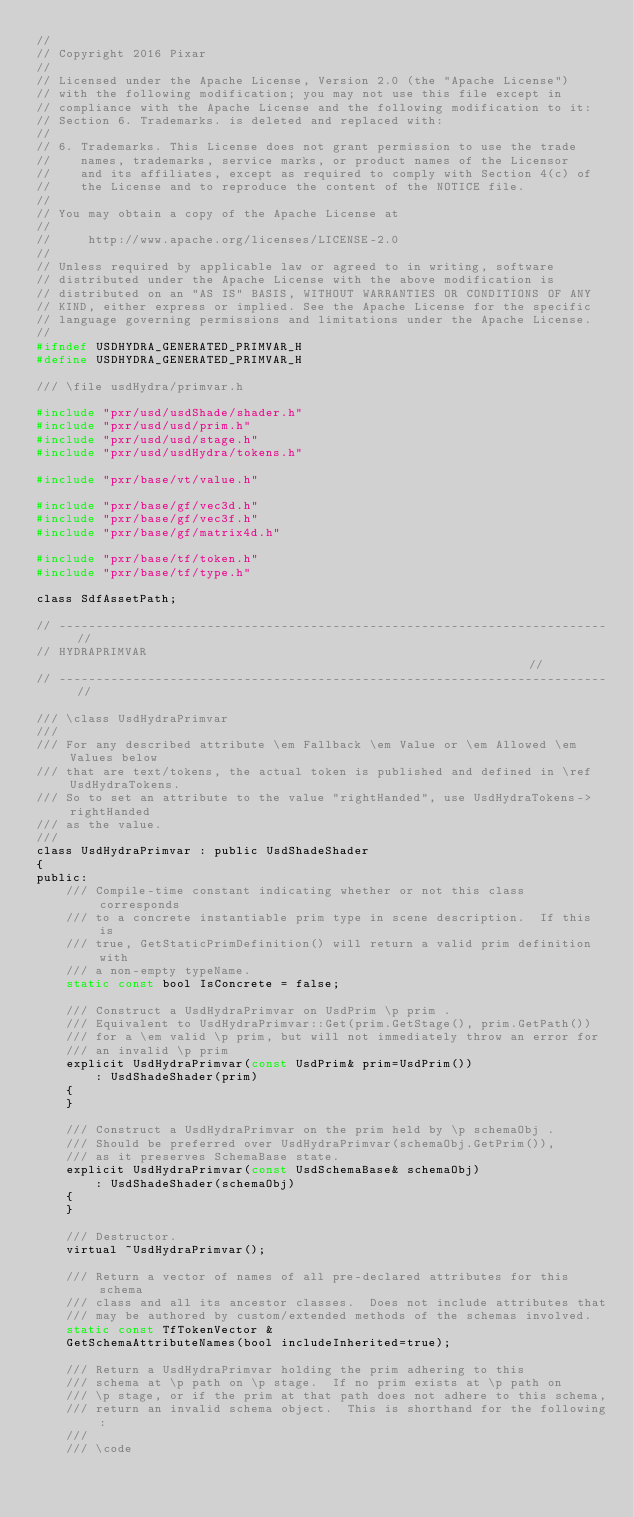<code> <loc_0><loc_0><loc_500><loc_500><_C_>//
// Copyright 2016 Pixar
//
// Licensed under the Apache License, Version 2.0 (the "Apache License")
// with the following modification; you may not use this file except in
// compliance with the Apache License and the following modification to it:
// Section 6. Trademarks. is deleted and replaced with:
//
// 6. Trademarks. This License does not grant permission to use the trade
//    names, trademarks, service marks, or product names of the Licensor
//    and its affiliates, except as required to comply with Section 4(c) of
//    the License and to reproduce the content of the NOTICE file.
//
// You may obtain a copy of the Apache License at
//
//     http://www.apache.org/licenses/LICENSE-2.0
//
// Unless required by applicable law or agreed to in writing, software
// distributed under the Apache License with the above modification is
// distributed on an "AS IS" BASIS, WITHOUT WARRANTIES OR CONDITIONS OF ANY
// KIND, either express or implied. See the Apache License for the specific
// language governing permissions and limitations under the Apache License.
//
#ifndef USDHYDRA_GENERATED_PRIMVAR_H
#define USDHYDRA_GENERATED_PRIMVAR_H

/// \file usdHydra/primvar.h

#include "pxr/usd/usdShade/shader.h"
#include "pxr/usd/usd/prim.h"
#include "pxr/usd/usd/stage.h"
#include "pxr/usd/usdHydra/tokens.h"

#include "pxr/base/vt/value.h"

#include "pxr/base/gf/vec3d.h"
#include "pxr/base/gf/vec3f.h"
#include "pxr/base/gf/matrix4d.h"

#include "pxr/base/tf/token.h"
#include "pxr/base/tf/type.h"

class SdfAssetPath;

// -------------------------------------------------------------------------- //
// HYDRAPRIMVAR                                                               //
// -------------------------------------------------------------------------- //

/// \class UsdHydraPrimvar
///
/// For any described attribute \em Fallback \em Value or \em Allowed \em Values below
/// that are text/tokens, the actual token is published and defined in \ref UsdHydraTokens.
/// So to set an attribute to the value "rightHanded", use UsdHydraTokens->rightHanded
/// as the value.
///
class UsdHydraPrimvar : public UsdShadeShader
{
public:
    /// Compile-time constant indicating whether or not this class corresponds
    /// to a concrete instantiable prim type in scene description.  If this is
    /// true, GetStaticPrimDefinition() will return a valid prim definition with
    /// a non-empty typeName.
    static const bool IsConcrete = false;

    /// Construct a UsdHydraPrimvar on UsdPrim \p prim .
    /// Equivalent to UsdHydraPrimvar::Get(prim.GetStage(), prim.GetPath())
    /// for a \em valid \p prim, but will not immediately throw an error for
    /// an invalid \p prim
    explicit UsdHydraPrimvar(const UsdPrim& prim=UsdPrim())
        : UsdShadeShader(prim)
    {
    }

    /// Construct a UsdHydraPrimvar on the prim held by \p schemaObj .
    /// Should be preferred over UsdHydraPrimvar(schemaObj.GetPrim()),
    /// as it preserves SchemaBase state.
    explicit UsdHydraPrimvar(const UsdSchemaBase& schemaObj)
        : UsdShadeShader(schemaObj)
    {
    }

    /// Destructor.
    virtual ~UsdHydraPrimvar();

    /// Return a vector of names of all pre-declared attributes for this schema
    /// class and all its ancestor classes.  Does not include attributes that
    /// may be authored by custom/extended methods of the schemas involved.
    static const TfTokenVector &
    GetSchemaAttributeNames(bool includeInherited=true);

    /// Return a UsdHydraPrimvar holding the prim adhering to this
    /// schema at \p path on \p stage.  If no prim exists at \p path on
    /// \p stage, or if the prim at that path does not adhere to this schema,
    /// return an invalid schema object.  This is shorthand for the following:
    ///
    /// \code</code> 